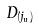<formula> <loc_0><loc_0><loc_500><loc_500>D _ { ( j _ { u } ) }</formula> 